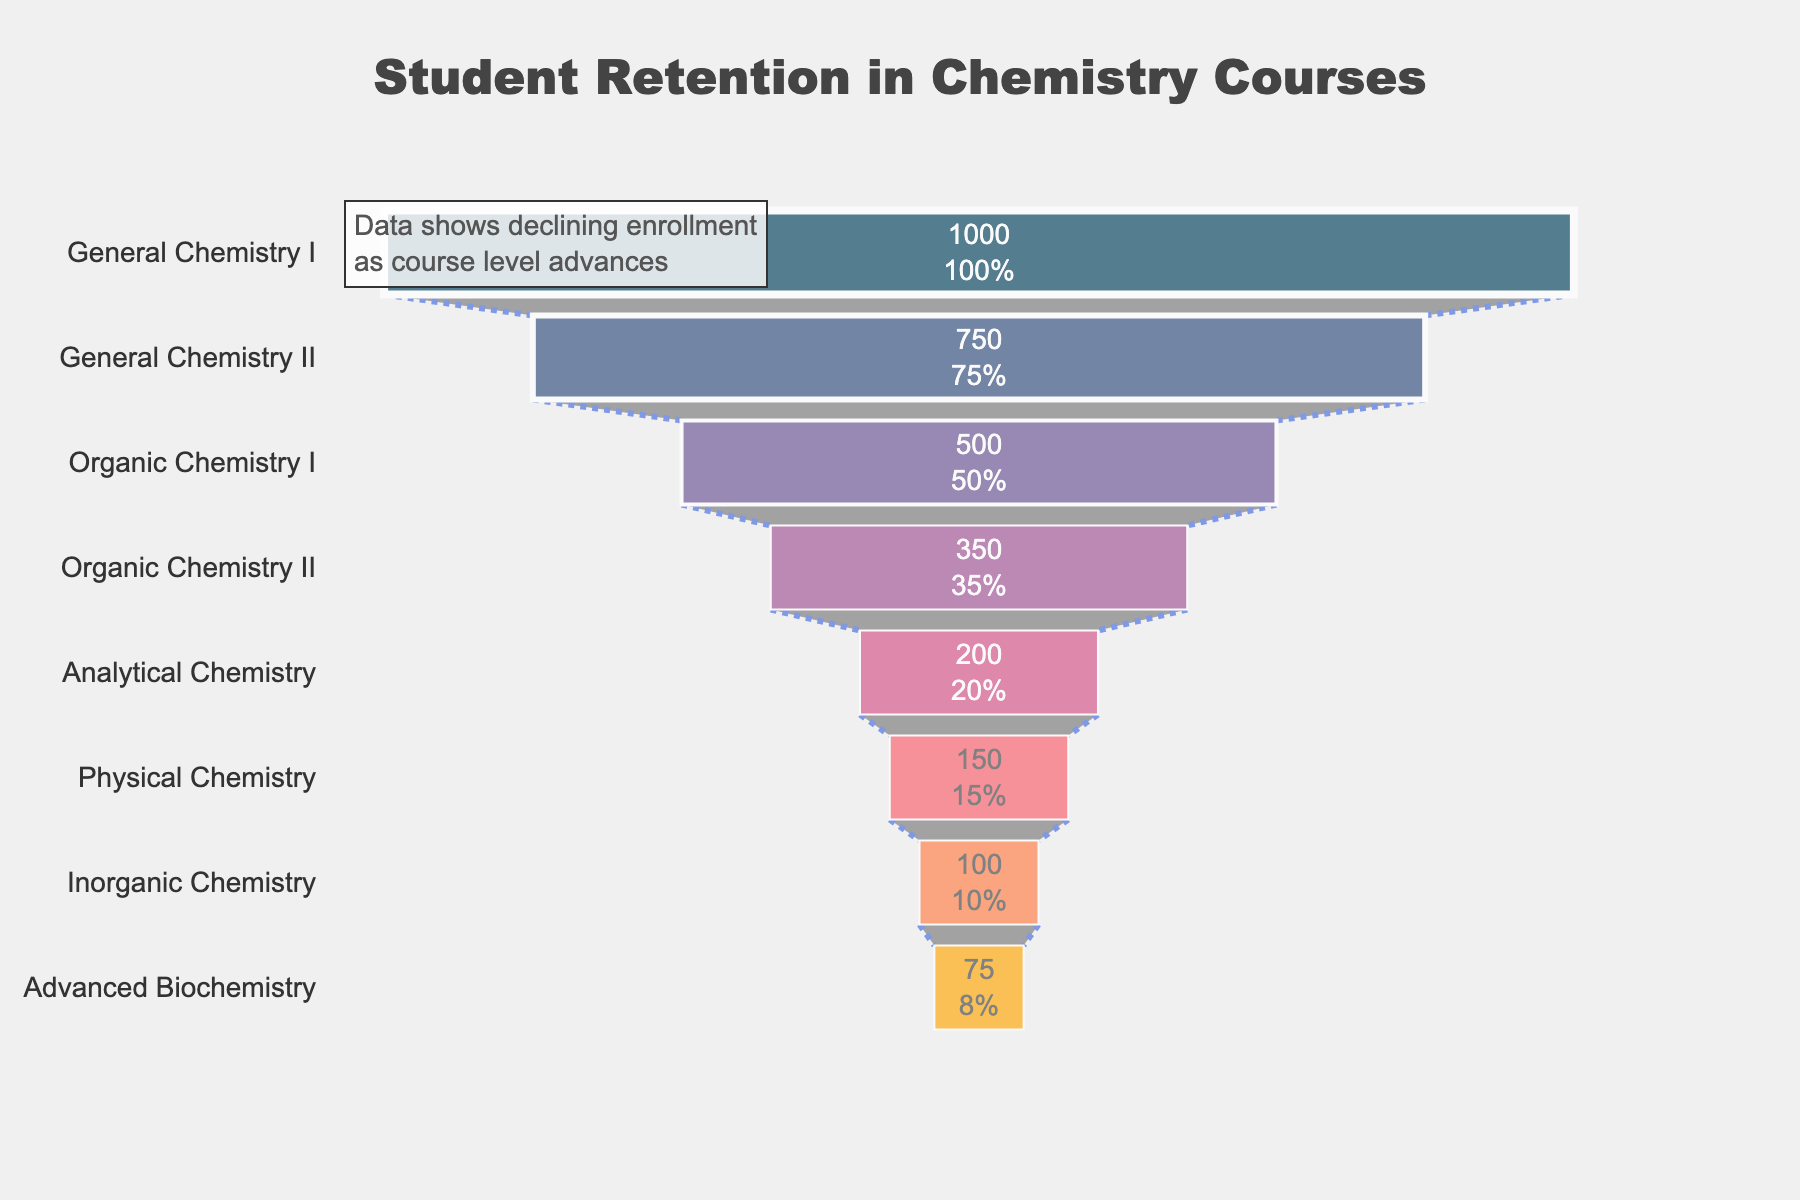What's the title of the funnel chart? The title of the funnel chart is given at the top of the figure.
Answer: "Student Retention in Chemistry Courses" How many course levels are shown in the funnel chart? Count the different labels on the y-axis of the funnel chart.
Answer: 8 Which course level has the highest number of students enrolled? The course at the widest part of the funnel indicates the highest enrollment.
Answer: General Chemistry I What is the percentage drop in student enrollment from General Chemistry I to General Chemistry II? Initial percentage in funnel charts often compares to the initial figure.
Answer: 25% What is the total number of students enrolled across all course levels? Add the number of students enrolled at each level: 1000 + 750 + 500 + 350 + 200 + 150 + 100 + 75.
Answer: 3125 Which course has the least number of students enrolled? The narrowest part of the funnel indicates the smallest enrollment.
Answer: Advanced Biochemistry How does the student retention change as course level advances from General Chemistry I to Advanced Biochemistry? Observe the trend from the widest part to the narrowest part of the funnel indicating decreasing student numbers.
Answer: Decreases What is the average number of students enrolled across all course levels? Sum all enrollments and divide by the number of course levels: (1000+750+500+350+200+150+100+75) / 8.
Answer: 390.625 Compare the enrollment between Organic Chemistry I and Organic Chemistry II. Organic Chemistry I has 500 students, while Organic Chemistry II has 350 students. Compare these numbers.
Answer: Organic Chemistry I has more students than Organic Chemistry II How many students are lost between Analytical Chemistry and Physical Chemistry? Subtract the number of students enrolled in Physical Chemistry from those in Analytical Chemistry: 200 - 150.
Answer: 50 